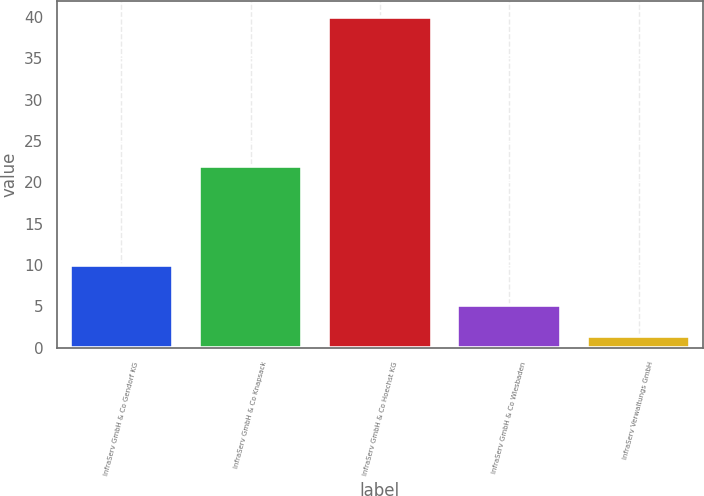Convert chart. <chart><loc_0><loc_0><loc_500><loc_500><bar_chart><fcel>InfraServ GmbH & Co Gendorf KG<fcel>InfraServ GmbH & Co Knapsack<fcel>InfraServ GmbH & Co Hoechst KG<fcel>InfraServ GmbH & Co Wiesbaden<fcel>InfraServ Verwaltungs GmbH<nl><fcel>10<fcel>22<fcel>40<fcel>5.23<fcel>1.37<nl></chart> 